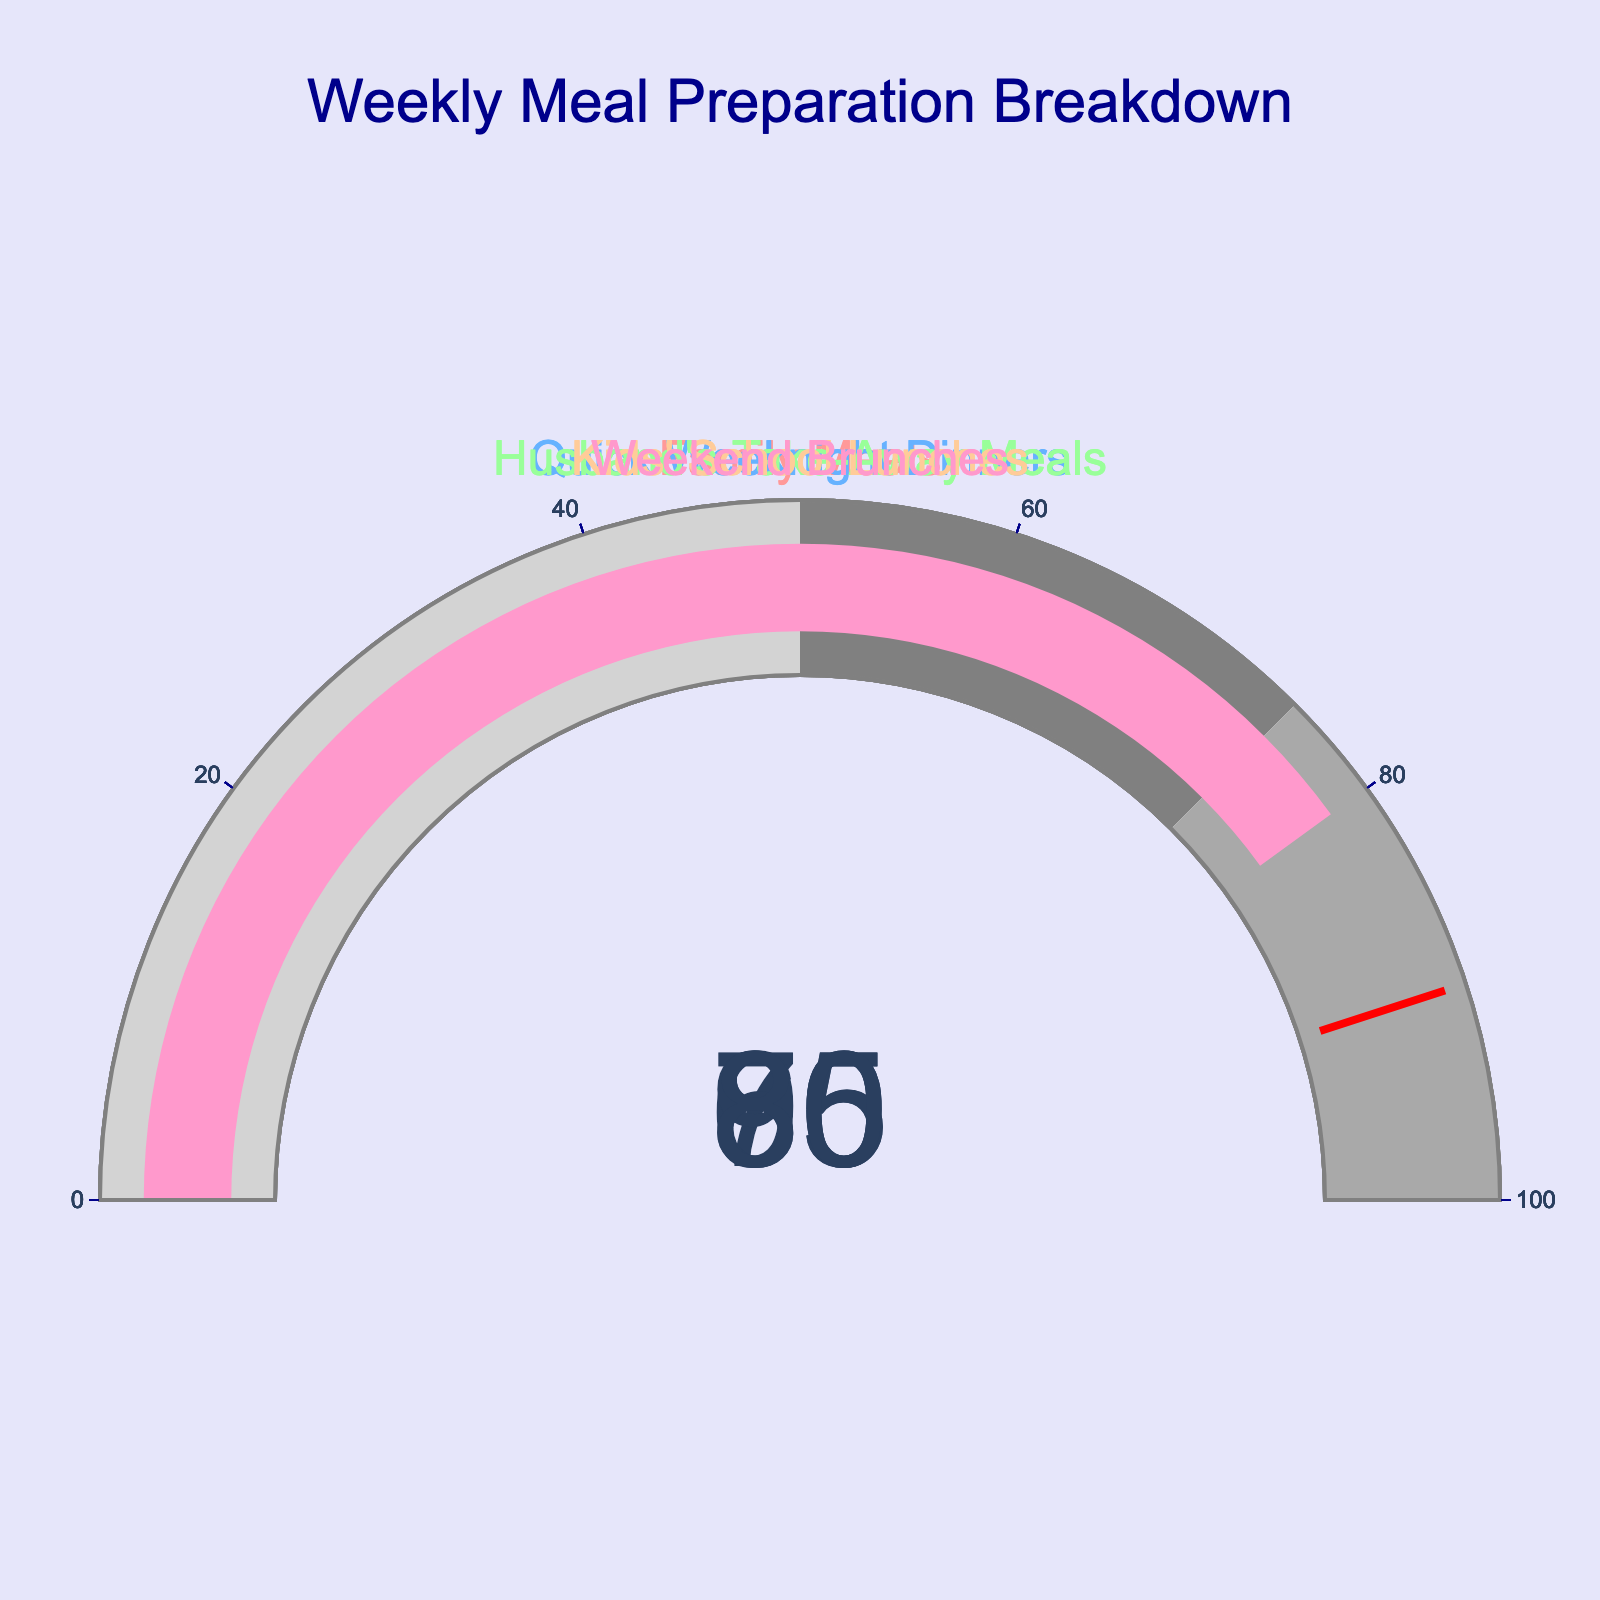What's the percentage of meals prepared at home for Family Meals? The gauge for Family Meals shows a percentage value, which can be directly read from the figure.
Answer: 85% How many categories have meal preparation percentages above 75%? To find the number of categories above 75%, look at the gauge values and count those higher than 75%. Family Meals (85%), Kids' School Lunches (95%), and Weekend Brunches (80%) are above 75%.
Answer: 3 Which category has the highest percentage of meals prepared at home? Compare the values on all the gauges. The highest value is 95% in the category Kids' School Lunches.
Answer: Kids' School Lunches What is the average percentage of meals prepared at home across all categories? Sum all the percentages and divide by the number of categories: (85 + 70 + 60 + 95 + 80) / 5 = 78.
Answer: 78 Which categories have meal preparation percentages less than Quick Weeknight Dinners? Identify categories with lower percentages than Quick Weeknight Dinners (70%). Husband's Take-Away Meals (60%) is the only one.
Answer: Husband's Take-Away Meals How much higher is the meal preparation percentage for Family Meals than Husband's Take-Away Meals? Subtract the percentage for Husband's Take-Away Meals (60%) from the percentage for Family Meals (85%), resulting in a difference of 25%.
Answer: 25% What is the total combined percentage for Weekend Brunches and Husband's Take-Away Meals? Add the percentages for both categories: 80% (Weekend Brunches) + 60% (Husband's Take-Away Meals) = 140%.
Answer: 140 Is the meal preparation percentage for Weekend Brunches greater or lesser than the threshold value of 90%? Compare the percentage of Weekend Brunches (80%) to the threshold value (90%). 80% is less than 90%.
Answer: Lesser What is the difference in meal preparation percentage between Kids' School Lunches and Quick Weeknight Dinners? Subtract Quick Weeknight Dinners (70%) from Kids' School Lunches (95%): 95% - 70% = 25%.
Answer: 25% How does the preparations percentage for Quick Weeknight Dinners compare to Family Meals? Compare the gauges of Quick Weeknight Dinners (70%) and Family Meals (85%). Quick Weeknight Dinners has a lower percentage than Family Meals.
Answer: Lower 